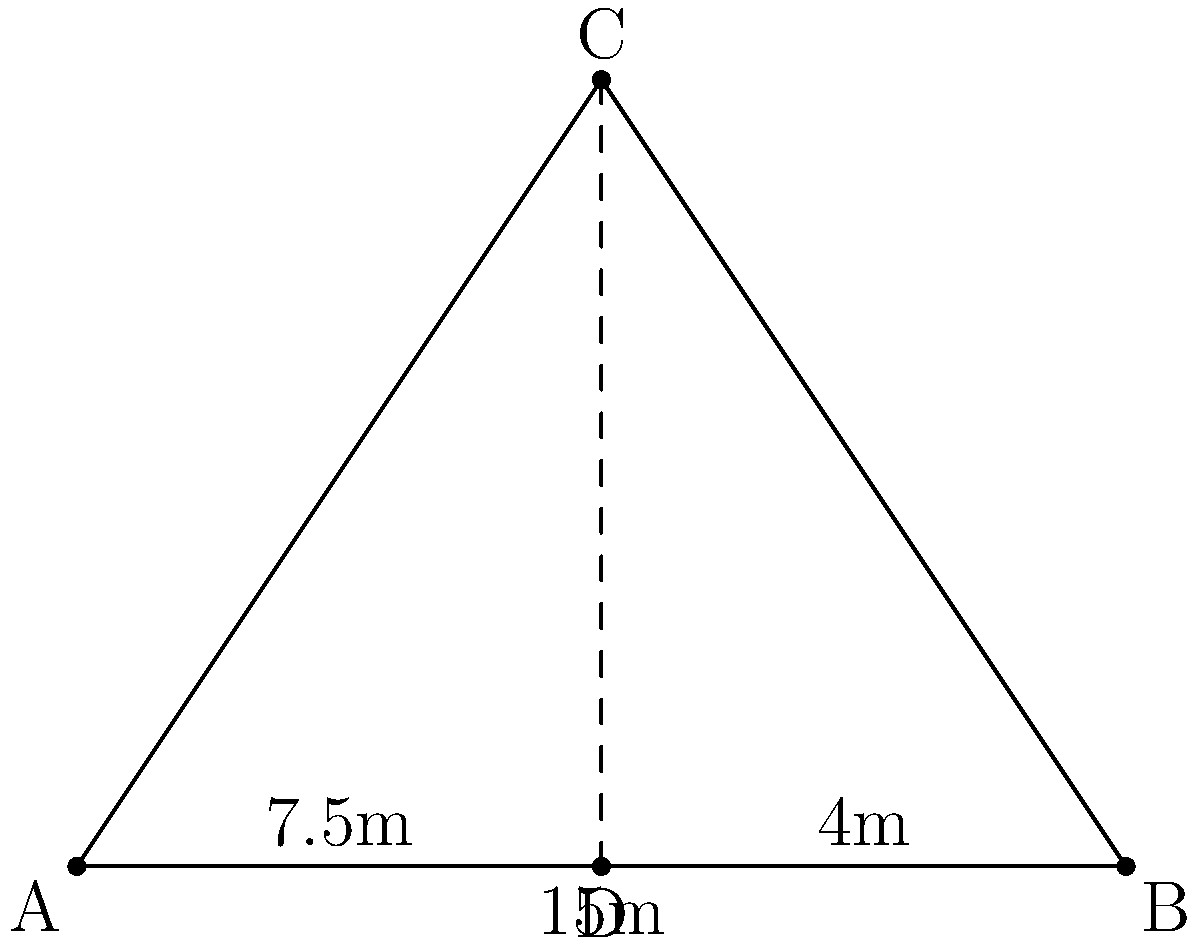A sports enthusiast wants to determine the height of a goal post. Standing 15 meters away from the base of the post, they observe that the top of the post aligns with their line of sight when they move 4 meters closer. If their eye level is 1.75 meters above the ground, what is the height of the goal post? Let's approach this step-by-step using similar triangles:

1) In the diagram, A represents the initial position, B the base of the goal post, C the top of the goal post, and D the closer position.

2) We can see that triangles ABC and ADC are similar.

3) Using the properties of similar triangles, we can set up the following proportion:

   $$\frac{BC}{DC} = \frac{AB}{AD}$$

4) We know:
   AB = 15m
   AD = 15m - 4m = 11m
   DC = 1.75m (eye level)

5) Let's say the height of the goal post (BC) is h. We can now write:

   $$\frac{h}{1.75} = \frac{15}{11}$$

6) Cross multiply:

   $$11h = 15 * 1.75$$

7) Solve for h:

   $$h = \frac{15 * 1.75}{11} = 2.386$$

Therefore, the height of the goal post is approximately 2.39 meters.
Answer: 2.39 meters 